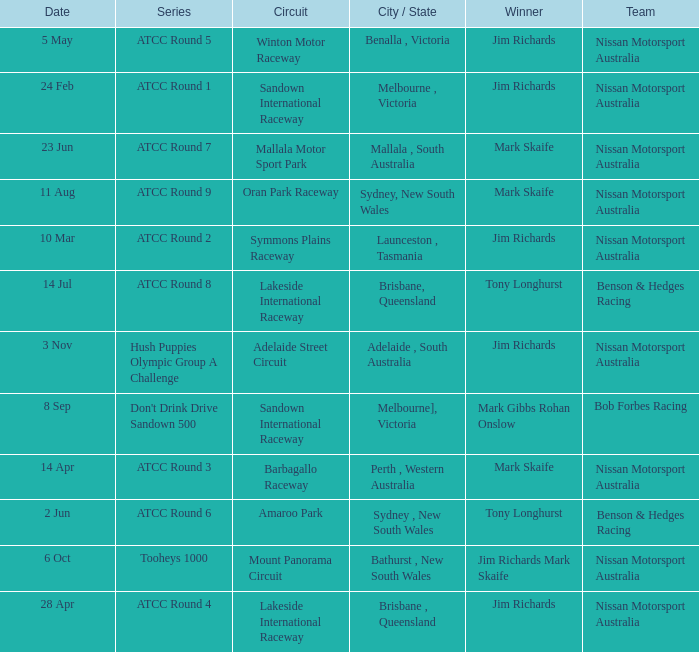Who is the Winner of the Nissan Motorsport Australia Team at the Oran Park Raceway? Mark Skaife. 